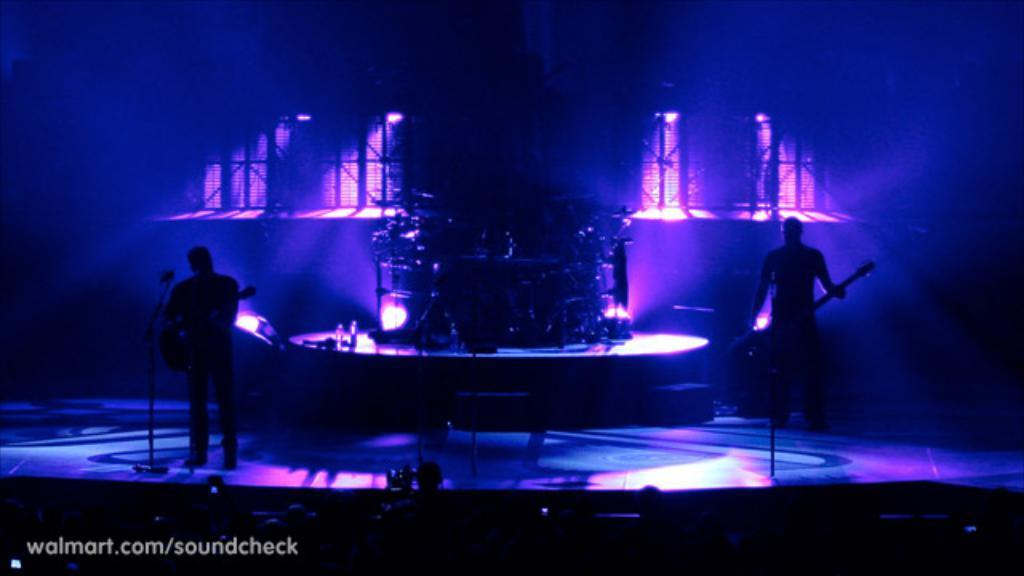Could you give a brief overview of what you see in this image? In the picture we can see a dark room inside it we can see a stage with two people are standing with a musical instruments and playing it and behind them we can see an orchestra and behind it we can see some lights focus. 